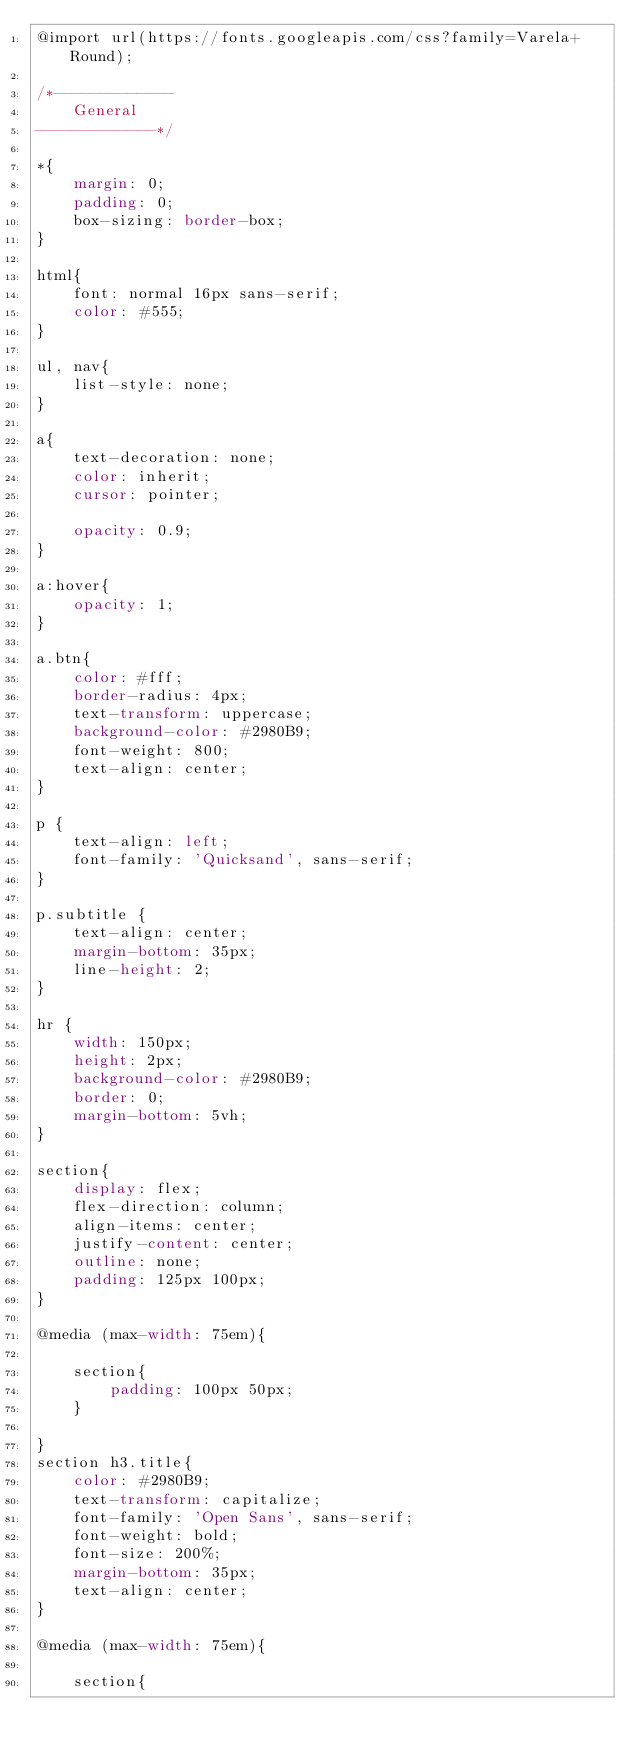Convert code to text. <code><loc_0><loc_0><loc_500><loc_500><_CSS_>@import url(https://fonts.googleapis.com/css?family=Varela+Round);

/*-------------
 	General
-------------*/

*{
	margin: 0;
	padding: 0;
	box-sizing: border-box;
}

html{
	font: normal 16px sans-serif;
	color: #555;
}

ul, nav{
	list-style: none;
}

a{
	text-decoration: none;
	color: inherit;
	cursor: pointer;

	opacity: 0.9;
}

a:hover{
	opacity: 1;
}

a.btn{
	color: #fff;
	border-radius: 4px;
	text-transform: uppercase;
	background-color: #2980B9;
	font-weight: 800;
	text-align: center;
}

p {
	text-align: left;
	font-family: 'Quicksand', sans-serif;
}

p.subtitle {
	text-align: center;
	margin-bottom: 35px;
	line-height: 2;
}

hr {
	width: 150px;
	height: 2px;
	background-color: #2980B9;
	border: 0;
	margin-bottom: 5vh;
}

section{
	display: flex;
	flex-direction: column;
	align-items: center;
	justify-content: center;
	outline: none;
	padding: 125px 100px;
}

@media (max-width: 75em){

	section{
		padding: 100px 50px;
	}

}
section h3.title{
	color: #2980B9;
	text-transform: capitalize; 
	font-family: 'Open Sans', sans-serif;
	font-weight: bold;
	font-size: 200%;
	margin-bottom: 35px;
	text-align: center;
}

@media (max-width: 75em){
	
	section{</code> 